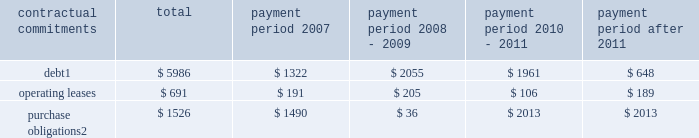Part ii , item 7 in 2006 , cash provided by financing activities was $ 291 million which was primarily due to the proceeds from employee stock plans ( $ 442 million ) and an increase in debt of $ 1.5 billion partially offset by the repurchase of 17.99 million shares of schlumberger stock ( $ 1.07 billion ) and the payment of dividends to shareholders ( $ 568 million ) .
Schlumberger believes that at december 31 , 2006 , cash and short-term investments of $ 3.0 billion and available and unused credit facilities of $ 2.2 billion are sufficient to meet future business requirements for at least the next twelve months .
Summary of major contractual commitments ( stated in millions ) .
Purchase obligations 2 $ 1526 $ 1490 $ 36 $ 2013 $ 2013 1 .
Excludes future payments for interest .
Includes amounts relating to the $ 1425 million of convertible debentures which are described in note 11 of the consolidated financial statements .
Represents an estimate of contractual obligations in the ordinary course of business .
Although these contractual obligations are considered enforceable and legally binding , the terms generally allow schlumberger the option to reschedule and adjust their requirements based on business needs prior to the delivery of goods .
Refer to note 4 of the consolidated financial statements for details regarding potential commitments associated with schlumberger 2019s prior business acquisitions .
Refer to note 20 of the consolidated financial statements for details regarding schlumberger 2019s pension and other postretirement benefit obligations .
Schlumberger has outstanding letters of credit/guarantees which relate to business performance bonds , custom/excise tax commitments , facility lease/rental obligations , etc .
These were entered into in the ordinary course of business and are customary practices in the various countries where schlumberger operates .
Critical accounting policies and estimates the preparation of financial statements and related disclosures in conformity with accounting principles generally accepted in the united states requires schlumberger to make estimates and assumptions that affect the reported amounts of assets and liabilities , the disclosure of contingent assets and liabilities and the reported amounts of revenue and expenses .
The following accounting policies involve 201ccritical accounting estimates 201d because they are particularly dependent on estimates and assumptions made by schlumberger about matters that are inherently uncertain .
A summary of all of schlumberger 2019s significant accounting policies is included in note 2 to the consolidated financial statements .
Schlumberger bases its estimates on historical experience and on various other assumptions that are believed to be reasonable under the circumstances , the results of which form the basis for making judgments about the carrying values of assets and liabilities that are not readily apparent from other sources .
Actual results may differ from these estimates under different assumptions or conditions .
Multiclient seismic data the westerngeco segment capitalizes the costs associated with obtaining multiclient seismic data .
The carrying value of the multiclient seismic data library at december 31 , 2006 , 2005 and 2004 was $ 227 million , $ 222 million and $ 347 million , respectively .
Such costs are charged to cost of goods sold and services based on the percentage of the total costs to the estimated total revenue that schlumberger expects to receive from the sales of such data .
However , except as described below under 201cwesterngeco purchase accounting , 201d under no circumstance will an individual survey carry a net book value greater than a 4-year straight-lined amortized value. .
What is the percent of the operating leases in 2007 as part of the total amount? 
Rationale: the percent is the 2007 amount divided by the total amount
Computations: (191 / 691)
Answer: 0.27641. 